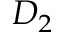Convert formula to latex. <formula><loc_0><loc_0><loc_500><loc_500>D _ { 2 }</formula> 